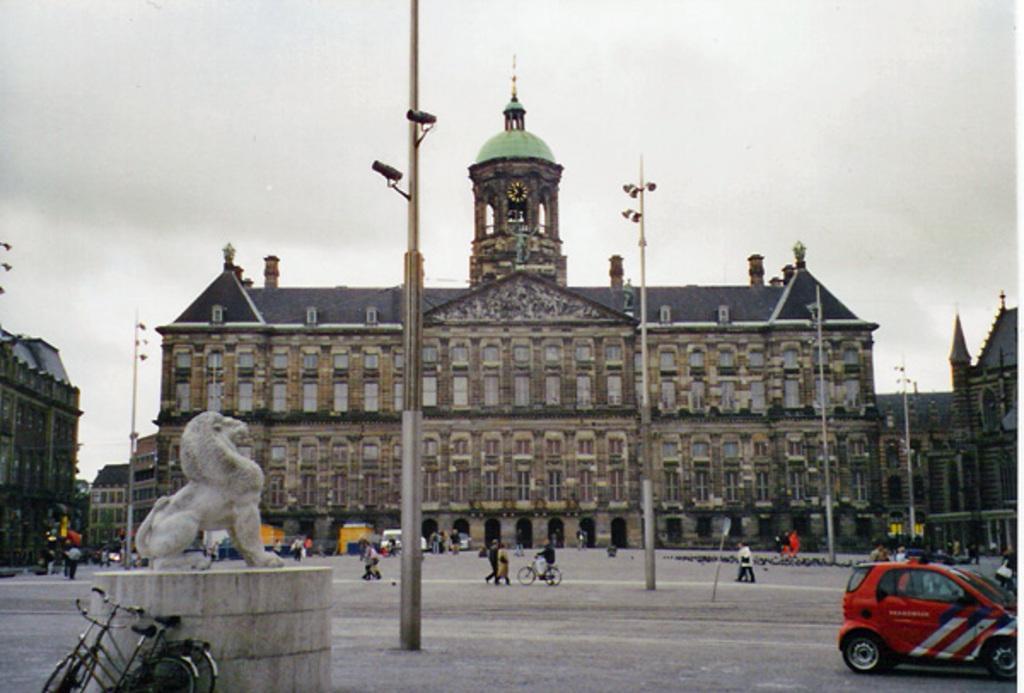Could you give a brief overview of what you see in this image? In this image I can see the ground, few poles, few cameras, an animal statue, few bicycles, a car and few persons. In the background I can see few buildings and the sky. 